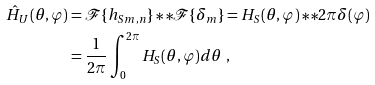<formula> <loc_0><loc_0><loc_500><loc_500>\hat { H } _ { U } ( \theta , \varphi ) & = \mathcal { F } \{ { h _ { S } } _ { m , n } \} \ast \ast \mathcal { F } \{ \delta _ { m } \} = H _ { S } ( \theta , \varphi ) \ast \ast 2 \pi \delta ( \varphi ) \\ & = \frac { 1 } { 2 \pi } \int _ { 0 } ^ { 2 \pi } H _ { S } ( \theta , \varphi ) d \theta \ ,</formula> 